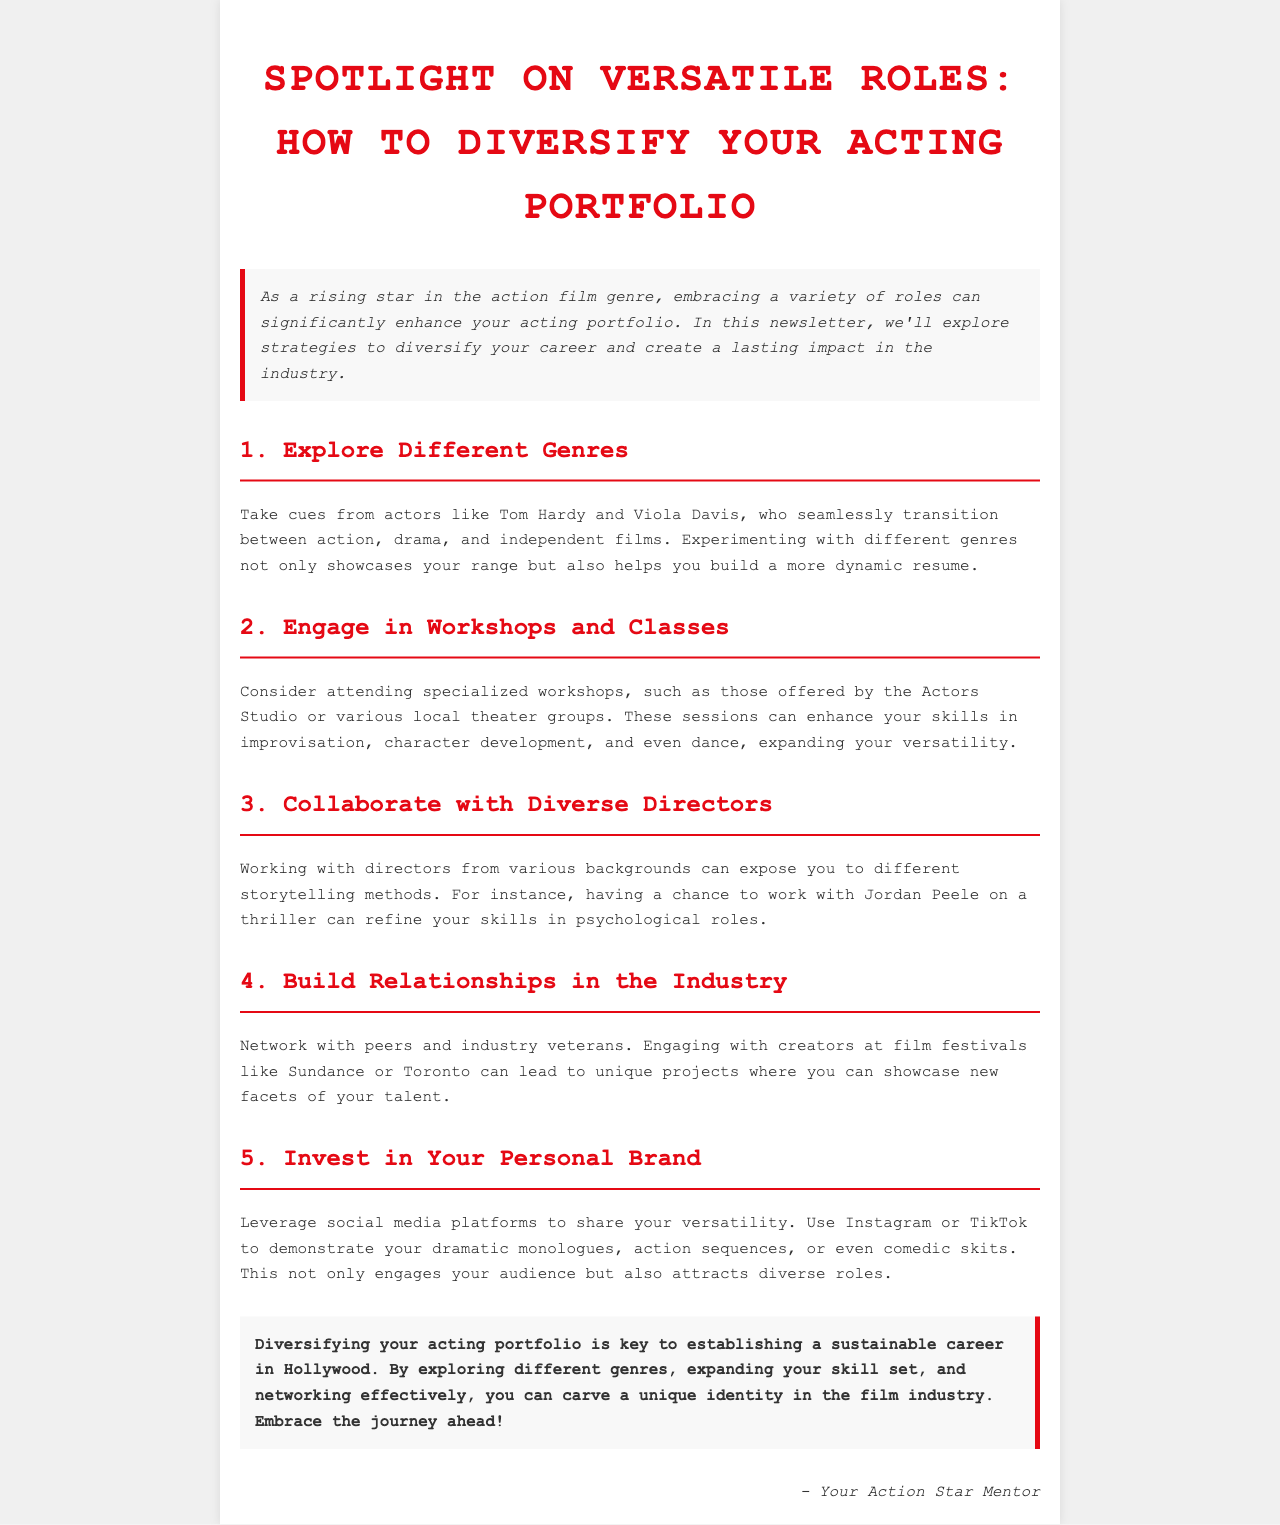What is the title of the newsletter? The title is the main heading of the document, which encapsulates the overall theme, "Spotlight on Versatile Roles: How to Diversify Your Acting Portfolio."
Answer: Spotlight on Versatile Roles: How to Diversify Your Acting Portfolio Who are the example actors mentioned for exploring different genres? The document specifies actors that demonstrate the ability to work across multiple genres, specifically Tom Hardy and Viola Davis.
Answer: Tom Hardy and Viola Davis What is one benefit of engaging in workshops and classes? The document mentions that attending workshops can enhance skills in various areas, specifically in improvisation, character development, and even dance.
Answer: Enhance skills Name one platform suggested for building a personal brand. The document lists social media platforms, specifically Instagram and TikTok, as tools for showcasing versatility.
Answer: Instagram or TikTok Which director is mentioned as an example for collaboration? The document highlights Jordan Peele as a director whose work can help refine skills in psychological roles through collaboration.
Answer: Jordan Peele What is the final takeaway emphasized in the conclusion? The conclusion stresses the importance of diversifying one's acting portfolio as a key strategy for establishing a sustainable career.
Answer: Diversifying your acting portfolio What is the intended audience of the newsletter? The newsletter is aimed at rising stars in the acting industry looking to expand their career opportunities and skills.
Answer: Rising stars in action films What color is used for the headings in the newsletter? The document uses a specific color for the headings, which is indicated as #e50914 in the CSS styling.
Answer: #e50914 